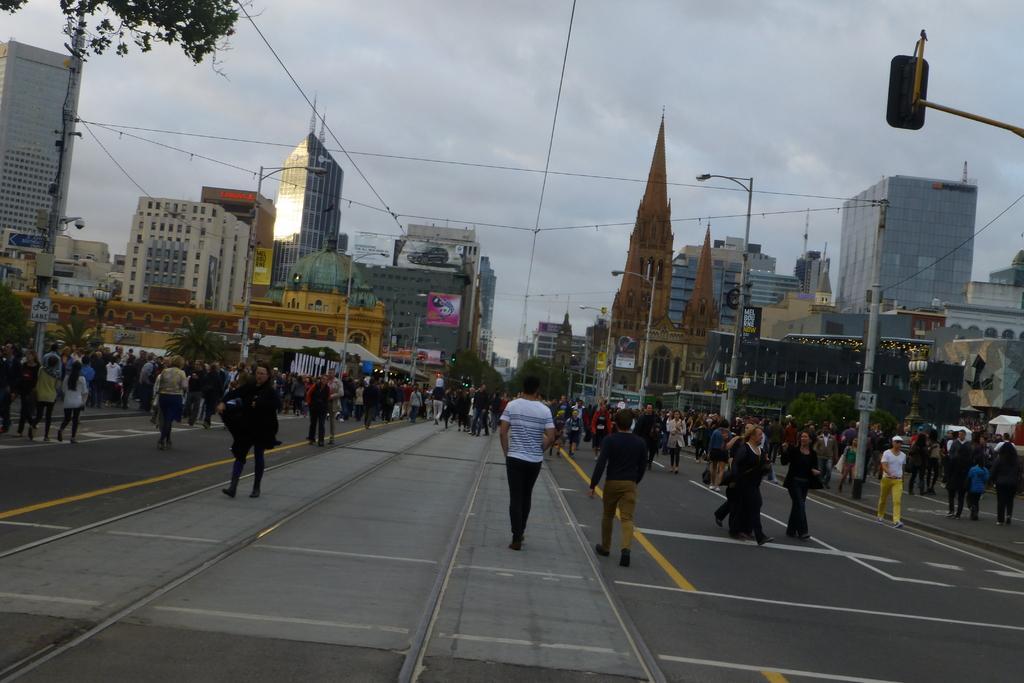Please provide a concise description of this image. At the bottom of the image there is a road. On the road there are many people walking. In the background there are many buildings, poles with street light, traffic lights. And also there are few electrical poles with wires and also there are few trees. At the top of the image there is a sky with clouds. 